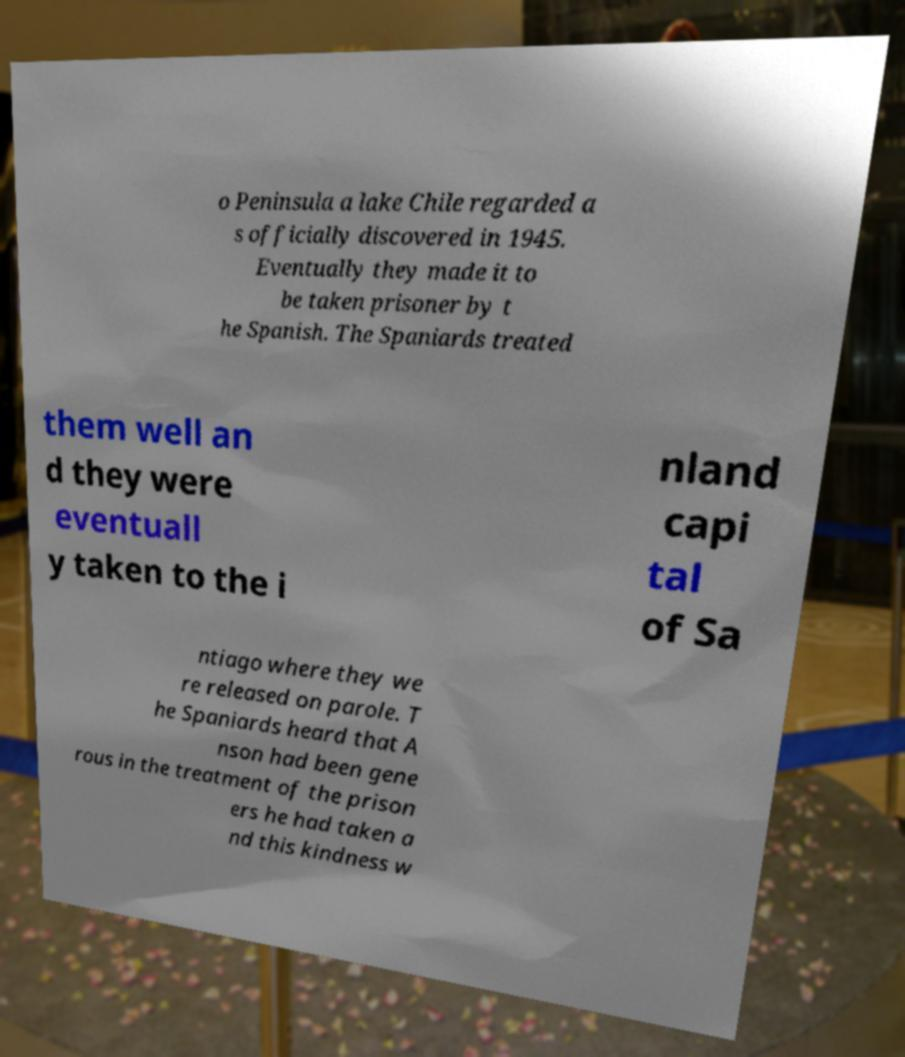There's text embedded in this image that I need extracted. Can you transcribe it verbatim? o Peninsula a lake Chile regarded a s officially discovered in 1945. Eventually they made it to be taken prisoner by t he Spanish. The Spaniards treated them well an d they were eventuall y taken to the i nland capi tal of Sa ntiago where they we re released on parole. T he Spaniards heard that A nson had been gene rous in the treatment of the prison ers he had taken a nd this kindness w 